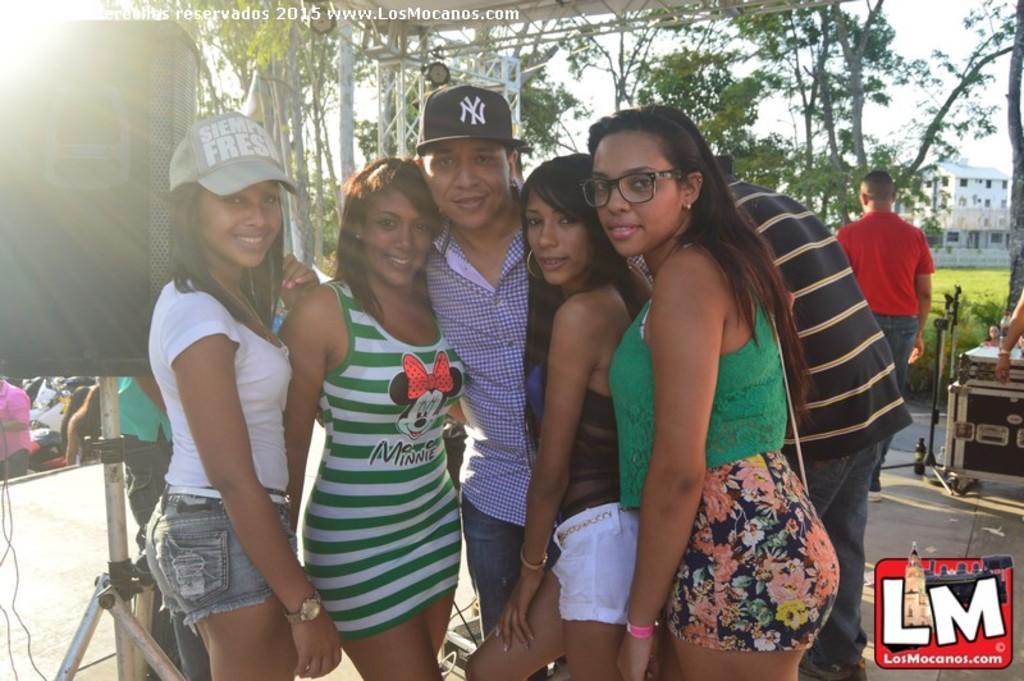How would you summarize this image in a sentence or two? In the center of the image we can see persons standing on the floor. In the background we can see trees, stands, buildings, person and grass. On the left side of the image we can see speaker and stand. 